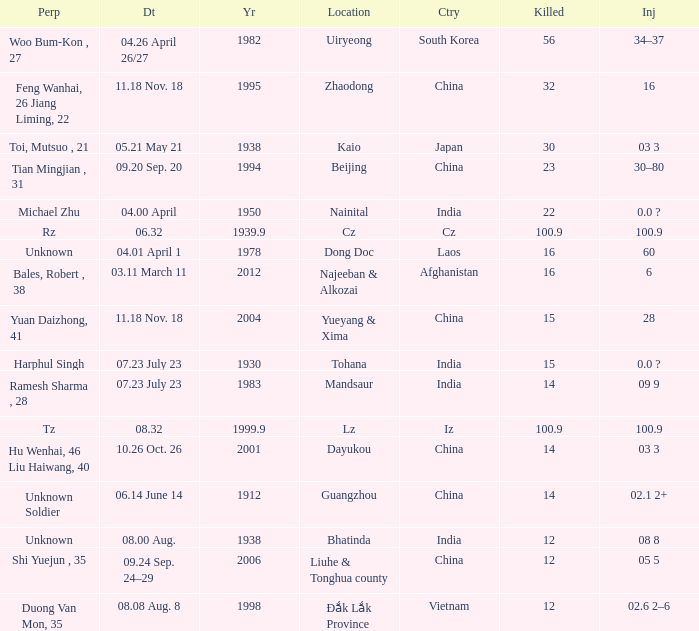What is Date, when Country is "China", and when Perpetrator is "Shi Yuejun , 35"? 09.24 Sep. 24–29. 